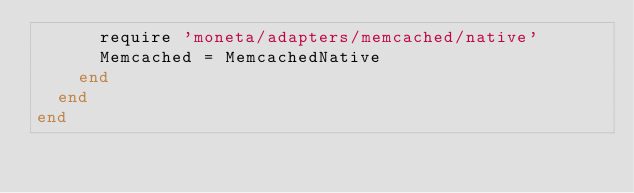<code> <loc_0><loc_0><loc_500><loc_500><_Ruby_>      require 'moneta/adapters/memcached/native'
      Memcached = MemcachedNative
    end
  end
end
</code> 